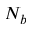<formula> <loc_0><loc_0><loc_500><loc_500>N _ { b }</formula> 